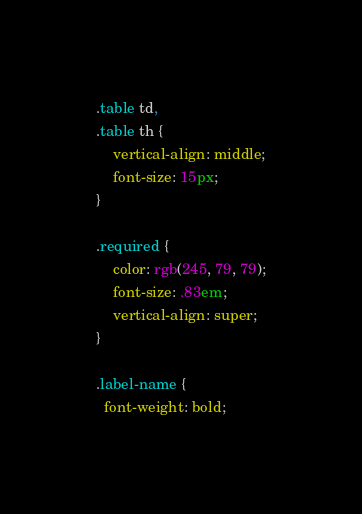<code> <loc_0><loc_0><loc_500><loc_500><_CSS_>.table td,
.table th {
    vertical-align: middle;
    font-size: 15px;
}

.required {
    color: rgb(245, 79, 79);
    font-size: .83em;
    vertical-align: super;
}

.label-name {
  font-weight: bold;</code> 